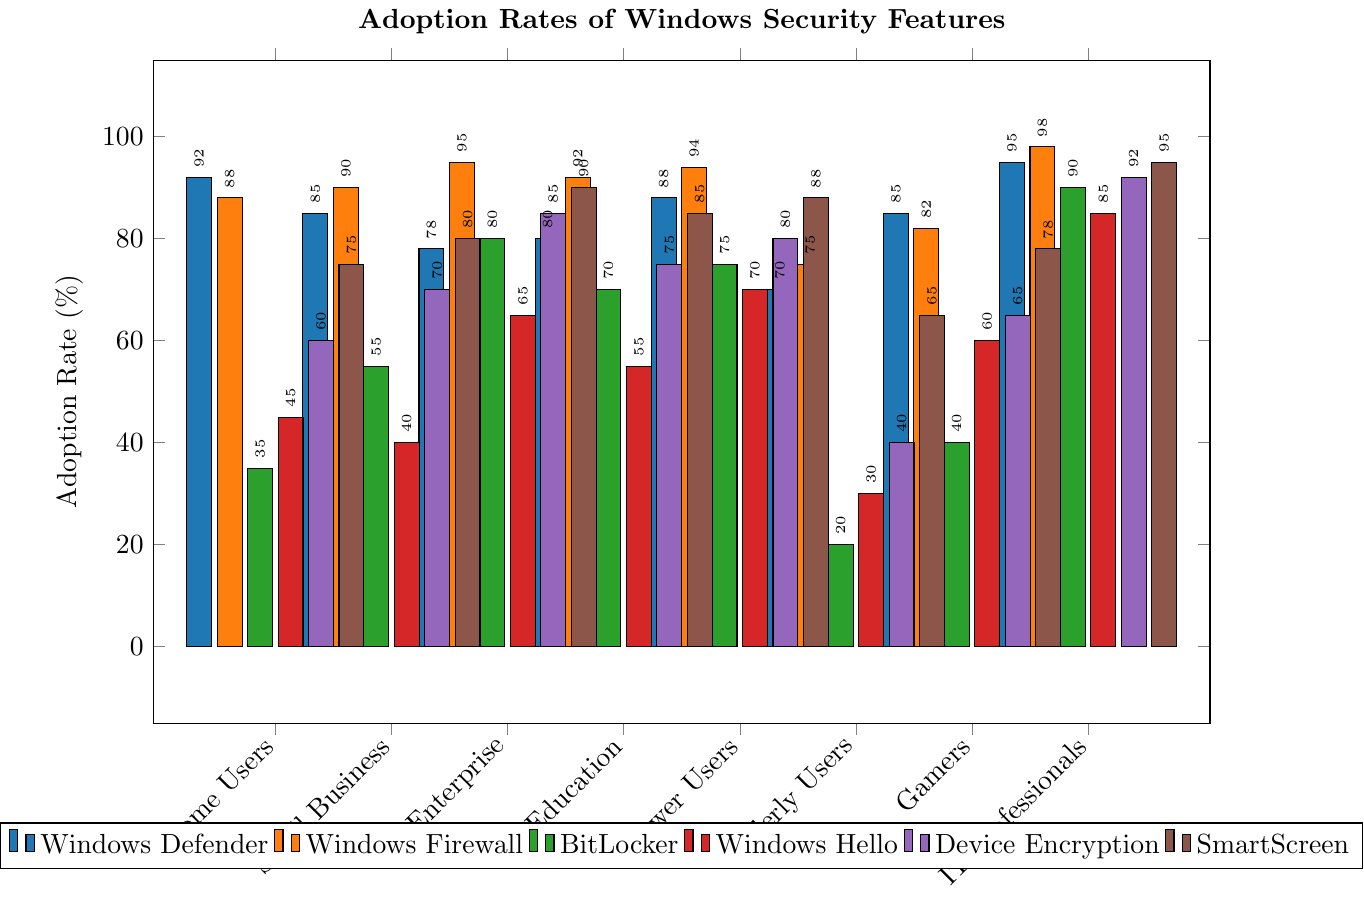What's the adoption rate of Windows Defender among Home Users and Enterprise users combined? To find the combined adoption rate, sum up the adoption rates for Home Users (92) and Enterprise users (78). The combined rate is 92 + 78 = 170.
Answer: 170 Which security feature has the highest adoption rate among IT Professionals? Check the adoption rates of all security features for IT Professionals and find the highest value. Windows Firewall has the highest adoption rate at 98.
Answer: Windows Firewall What is the difference in the adoption rate of BitLocker between Education and Small Business user groups? Identify the adoption rates of BitLocker for Education (70) and Small Business (55) groups. Subtract the smaller value from the larger one: 70 - 55 = 15.
Answer: 15 Which user group has the lowest adoption rate for Windows Hello? Compare the Windows Hello adoption rates across all user groups and find the lowest value. Elderly Users have the lowest rate at 30.
Answer: Elderly Users How much higher is the adoption rate of SmartScreen among Power Users compared to Elderly Users? Identify the adoption rates of SmartScreen for Power Users (88) and Elderly Users (65). Calculate the difference: 88 - 65 = 23.
Answer: 23 What's the average adoption rate of Device Encryption across all user groups? Sum the adoption rates for Device Encryption across all user groups (60, 70, 85, 75, 80, 40, 65, 92) and then divide by the number of groups (8): (60 + 70 + 85 + 75 + 80 + 40 + 65 + 92) / 8 = 567 / 8 = 70.875.
Answer: 70.875 Which user group has the most evenly distributed adoption rates across all security features? Compare the adoption rates for all security features for each user group, looking for the group with the smallest range in values. Power Users have the smallest range (from 70 to 94), indicating an even distribution.
Answer: Power Users Identify the security feature with the least variance in adoption rates across all user groups. Calculate the variance for each security feature across all user groups. This involves finding the mean adoption rate for each feature, then calculating the squared differences from the mean for each group and averaging them. Windows Firewall, with adoption rates mostly above 80, has the least variance.
Answer: Windows Firewall 